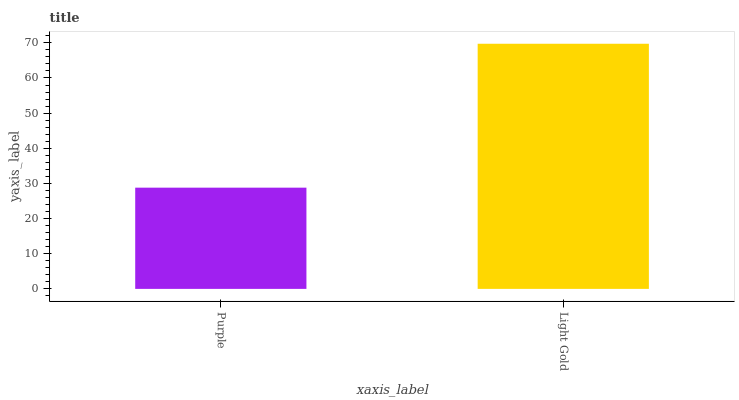Is Purple the minimum?
Answer yes or no. Yes. Is Light Gold the maximum?
Answer yes or no. Yes. Is Light Gold the minimum?
Answer yes or no. No. Is Light Gold greater than Purple?
Answer yes or no. Yes. Is Purple less than Light Gold?
Answer yes or no. Yes. Is Purple greater than Light Gold?
Answer yes or no. No. Is Light Gold less than Purple?
Answer yes or no. No. Is Light Gold the high median?
Answer yes or no. Yes. Is Purple the low median?
Answer yes or no. Yes. Is Purple the high median?
Answer yes or no. No. Is Light Gold the low median?
Answer yes or no. No. 